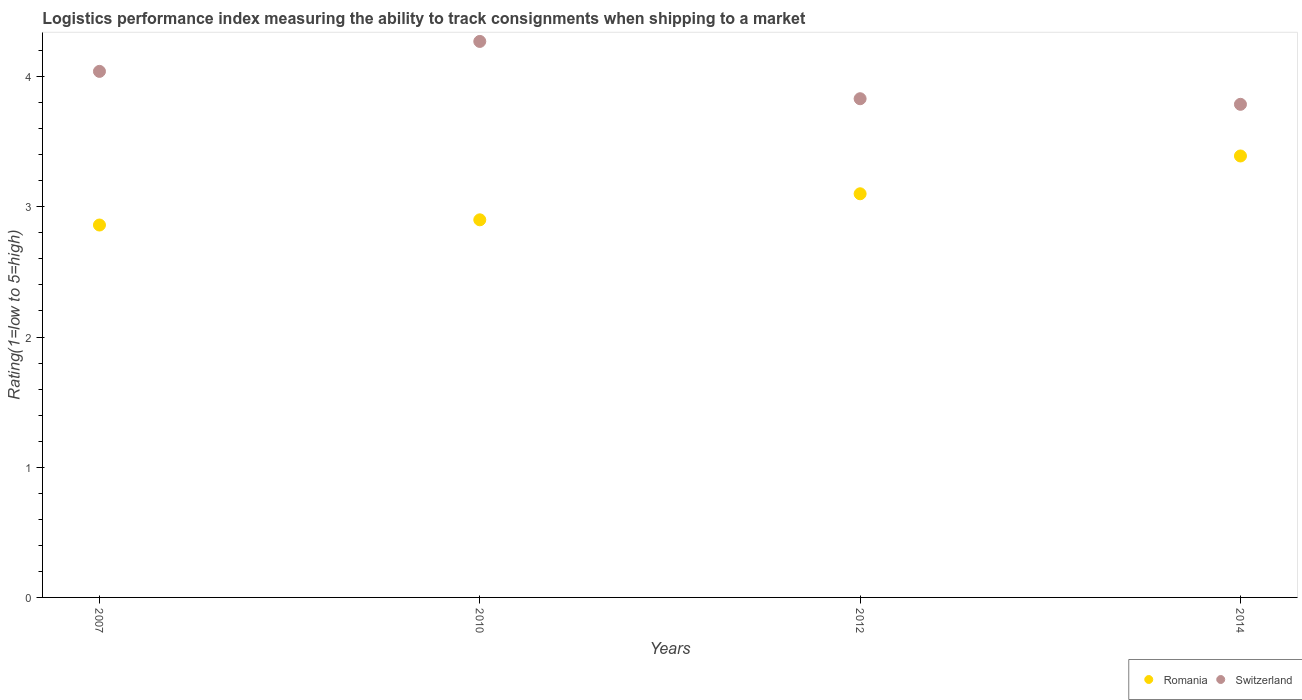How many different coloured dotlines are there?
Your answer should be compact. 2. Is the number of dotlines equal to the number of legend labels?
Provide a short and direct response. Yes. What is the Logistic performance index in Romania in 2014?
Give a very brief answer. 3.39. Across all years, what is the maximum Logistic performance index in Romania?
Offer a very short reply. 3.39. Across all years, what is the minimum Logistic performance index in Romania?
Make the answer very short. 2.86. In which year was the Logistic performance index in Romania minimum?
Make the answer very short. 2007. What is the total Logistic performance index in Romania in the graph?
Give a very brief answer. 12.25. What is the difference between the Logistic performance index in Switzerland in 2007 and that in 2014?
Provide a short and direct response. 0.25. What is the difference between the Logistic performance index in Romania in 2007 and the Logistic performance index in Switzerland in 2010?
Ensure brevity in your answer.  -1.41. What is the average Logistic performance index in Switzerland per year?
Offer a terse response. 3.98. In the year 2014, what is the difference between the Logistic performance index in Switzerland and Logistic performance index in Romania?
Offer a very short reply. 0.4. What is the ratio of the Logistic performance index in Switzerland in 2012 to that in 2014?
Make the answer very short. 1.01. Is the Logistic performance index in Switzerland in 2007 less than that in 2010?
Your answer should be compact. Yes. Is the difference between the Logistic performance index in Switzerland in 2007 and 2012 greater than the difference between the Logistic performance index in Romania in 2007 and 2012?
Provide a short and direct response. Yes. What is the difference between the highest and the second highest Logistic performance index in Switzerland?
Ensure brevity in your answer.  0.23. What is the difference between the highest and the lowest Logistic performance index in Switzerland?
Make the answer very short. 0.48. In how many years, is the Logistic performance index in Switzerland greater than the average Logistic performance index in Switzerland taken over all years?
Give a very brief answer. 2. Is the sum of the Logistic performance index in Romania in 2007 and 2010 greater than the maximum Logistic performance index in Switzerland across all years?
Offer a very short reply. Yes. Does the Logistic performance index in Switzerland monotonically increase over the years?
Your answer should be compact. No. Is the Logistic performance index in Switzerland strictly greater than the Logistic performance index in Romania over the years?
Keep it short and to the point. Yes. How many dotlines are there?
Give a very brief answer. 2. Does the graph contain any zero values?
Keep it short and to the point. No. Does the graph contain grids?
Your answer should be compact. No. How many legend labels are there?
Keep it short and to the point. 2. How are the legend labels stacked?
Provide a succinct answer. Horizontal. What is the title of the graph?
Offer a terse response. Logistics performance index measuring the ability to track consignments when shipping to a market. Does "Suriname" appear as one of the legend labels in the graph?
Your answer should be compact. No. What is the label or title of the Y-axis?
Your answer should be compact. Rating(1=low to 5=high). What is the Rating(1=low to 5=high) in Romania in 2007?
Make the answer very short. 2.86. What is the Rating(1=low to 5=high) of Switzerland in 2007?
Ensure brevity in your answer.  4.04. What is the Rating(1=low to 5=high) of Switzerland in 2010?
Offer a very short reply. 4.27. What is the Rating(1=low to 5=high) of Switzerland in 2012?
Your answer should be very brief. 3.83. What is the Rating(1=low to 5=high) in Romania in 2014?
Provide a succinct answer. 3.39. What is the Rating(1=low to 5=high) of Switzerland in 2014?
Ensure brevity in your answer.  3.79. Across all years, what is the maximum Rating(1=low to 5=high) of Romania?
Give a very brief answer. 3.39. Across all years, what is the maximum Rating(1=low to 5=high) in Switzerland?
Offer a terse response. 4.27. Across all years, what is the minimum Rating(1=low to 5=high) in Romania?
Offer a terse response. 2.86. Across all years, what is the minimum Rating(1=low to 5=high) in Switzerland?
Offer a terse response. 3.79. What is the total Rating(1=low to 5=high) of Romania in the graph?
Offer a very short reply. 12.25. What is the total Rating(1=low to 5=high) of Switzerland in the graph?
Provide a succinct answer. 15.93. What is the difference between the Rating(1=low to 5=high) in Romania in 2007 and that in 2010?
Keep it short and to the point. -0.04. What is the difference between the Rating(1=low to 5=high) of Switzerland in 2007 and that in 2010?
Make the answer very short. -0.23. What is the difference between the Rating(1=low to 5=high) of Romania in 2007 and that in 2012?
Offer a terse response. -0.24. What is the difference between the Rating(1=low to 5=high) in Switzerland in 2007 and that in 2012?
Ensure brevity in your answer.  0.21. What is the difference between the Rating(1=low to 5=high) of Romania in 2007 and that in 2014?
Ensure brevity in your answer.  -0.53. What is the difference between the Rating(1=low to 5=high) in Switzerland in 2007 and that in 2014?
Make the answer very short. 0.25. What is the difference between the Rating(1=low to 5=high) of Switzerland in 2010 and that in 2012?
Keep it short and to the point. 0.44. What is the difference between the Rating(1=low to 5=high) in Romania in 2010 and that in 2014?
Your answer should be very brief. -0.49. What is the difference between the Rating(1=low to 5=high) of Switzerland in 2010 and that in 2014?
Your answer should be very brief. 0.48. What is the difference between the Rating(1=low to 5=high) of Romania in 2012 and that in 2014?
Offer a very short reply. -0.29. What is the difference between the Rating(1=low to 5=high) of Switzerland in 2012 and that in 2014?
Make the answer very short. 0.04. What is the difference between the Rating(1=low to 5=high) in Romania in 2007 and the Rating(1=low to 5=high) in Switzerland in 2010?
Your response must be concise. -1.41. What is the difference between the Rating(1=low to 5=high) of Romania in 2007 and the Rating(1=low to 5=high) of Switzerland in 2012?
Provide a short and direct response. -0.97. What is the difference between the Rating(1=low to 5=high) in Romania in 2007 and the Rating(1=low to 5=high) in Switzerland in 2014?
Your answer should be very brief. -0.93. What is the difference between the Rating(1=low to 5=high) in Romania in 2010 and the Rating(1=low to 5=high) in Switzerland in 2012?
Offer a very short reply. -0.93. What is the difference between the Rating(1=low to 5=high) in Romania in 2010 and the Rating(1=low to 5=high) in Switzerland in 2014?
Offer a terse response. -0.89. What is the difference between the Rating(1=low to 5=high) in Romania in 2012 and the Rating(1=low to 5=high) in Switzerland in 2014?
Make the answer very short. -0.69. What is the average Rating(1=low to 5=high) in Romania per year?
Provide a short and direct response. 3.06. What is the average Rating(1=low to 5=high) in Switzerland per year?
Make the answer very short. 3.98. In the year 2007, what is the difference between the Rating(1=low to 5=high) of Romania and Rating(1=low to 5=high) of Switzerland?
Make the answer very short. -1.18. In the year 2010, what is the difference between the Rating(1=low to 5=high) of Romania and Rating(1=low to 5=high) of Switzerland?
Your answer should be compact. -1.37. In the year 2012, what is the difference between the Rating(1=low to 5=high) of Romania and Rating(1=low to 5=high) of Switzerland?
Your response must be concise. -0.73. In the year 2014, what is the difference between the Rating(1=low to 5=high) in Romania and Rating(1=low to 5=high) in Switzerland?
Ensure brevity in your answer.  -0.4. What is the ratio of the Rating(1=low to 5=high) of Romania in 2007 to that in 2010?
Provide a short and direct response. 0.99. What is the ratio of the Rating(1=low to 5=high) in Switzerland in 2007 to that in 2010?
Your answer should be very brief. 0.95. What is the ratio of the Rating(1=low to 5=high) in Romania in 2007 to that in 2012?
Offer a very short reply. 0.92. What is the ratio of the Rating(1=low to 5=high) in Switzerland in 2007 to that in 2012?
Keep it short and to the point. 1.05. What is the ratio of the Rating(1=low to 5=high) in Romania in 2007 to that in 2014?
Your answer should be very brief. 0.84. What is the ratio of the Rating(1=low to 5=high) of Switzerland in 2007 to that in 2014?
Provide a short and direct response. 1.07. What is the ratio of the Rating(1=low to 5=high) of Romania in 2010 to that in 2012?
Your response must be concise. 0.94. What is the ratio of the Rating(1=low to 5=high) of Switzerland in 2010 to that in 2012?
Your response must be concise. 1.11. What is the ratio of the Rating(1=low to 5=high) of Romania in 2010 to that in 2014?
Provide a succinct answer. 0.86. What is the ratio of the Rating(1=low to 5=high) of Switzerland in 2010 to that in 2014?
Offer a terse response. 1.13. What is the ratio of the Rating(1=low to 5=high) of Romania in 2012 to that in 2014?
Give a very brief answer. 0.91. What is the ratio of the Rating(1=low to 5=high) in Switzerland in 2012 to that in 2014?
Provide a short and direct response. 1.01. What is the difference between the highest and the second highest Rating(1=low to 5=high) of Romania?
Give a very brief answer. 0.29. What is the difference between the highest and the second highest Rating(1=low to 5=high) of Switzerland?
Give a very brief answer. 0.23. What is the difference between the highest and the lowest Rating(1=low to 5=high) of Romania?
Offer a terse response. 0.53. What is the difference between the highest and the lowest Rating(1=low to 5=high) of Switzerland?
Keep it short and to the point. 0.48. 